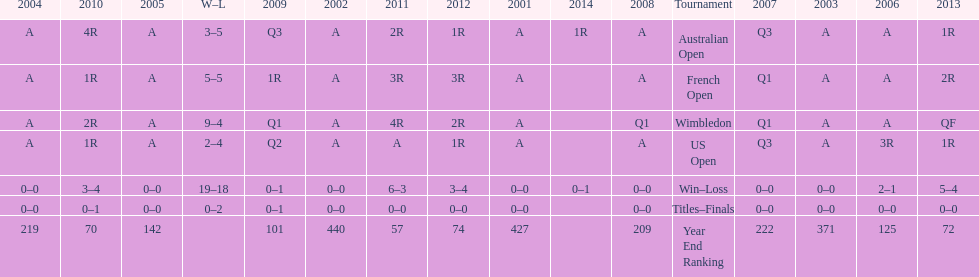Which competition has a 5-5 "win-loss" record? French Open. 